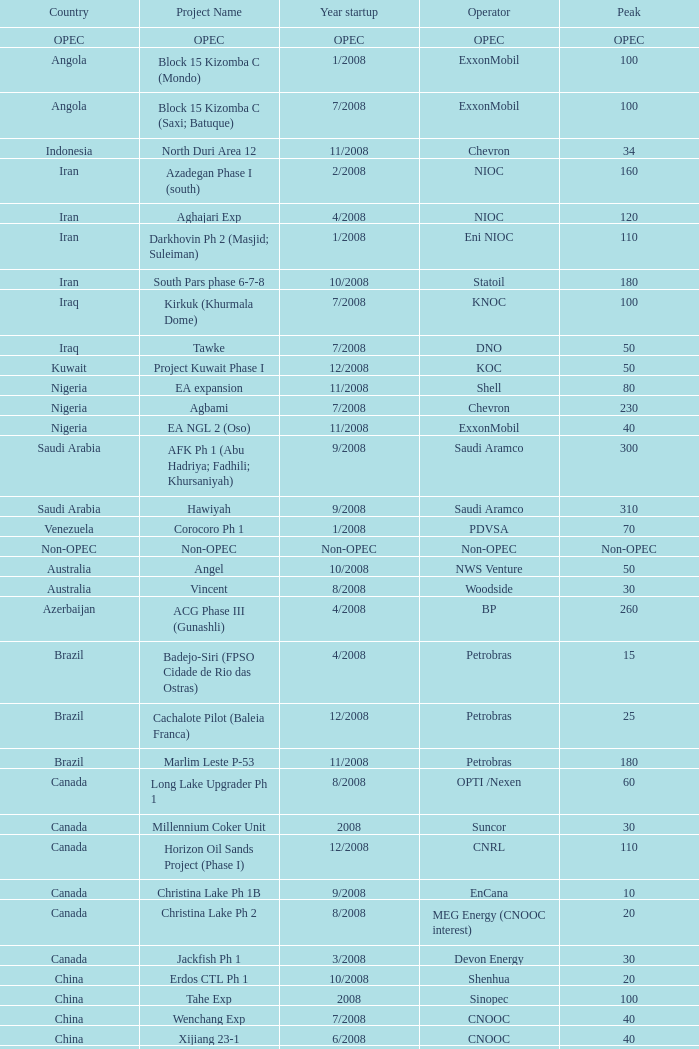Can you provide the project name that involves kazakhstan and has a peak of 150? Dunga. 